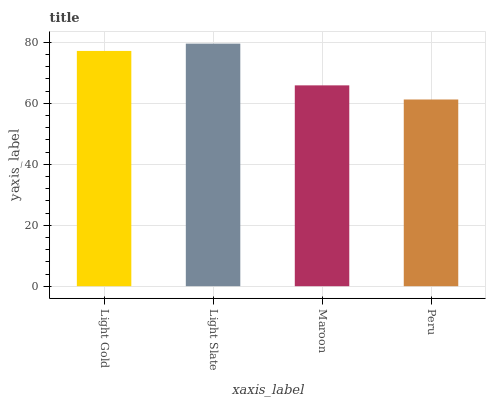Is Peru the minimum?
Answer yes or no. Yes. Is Light Slate the maximum?
Answer yes or no. Yes. Is Maroon the minimum?
Answer yes or no. No. Is Maroon the maximum?
Answer yes or no. No. Is Light Slate greater than Maroon?
Answer yes or no. Yes. Is Maroon less than Light Slate?
Answer yes or no. Yes. Is Maroon greater than Light Slate?
Answer yes or no. No. Is Light Slate less than Maroon?
Answer yes or no. No. Is Light Gold the high median?
Answer yes or no. Yes. Is Maroon the low median?
Answer yes or no. Yes. Is Maroon the high median?
Answer yes or no. No. Is Light Slate the low median?
Answer yes or no. No. 